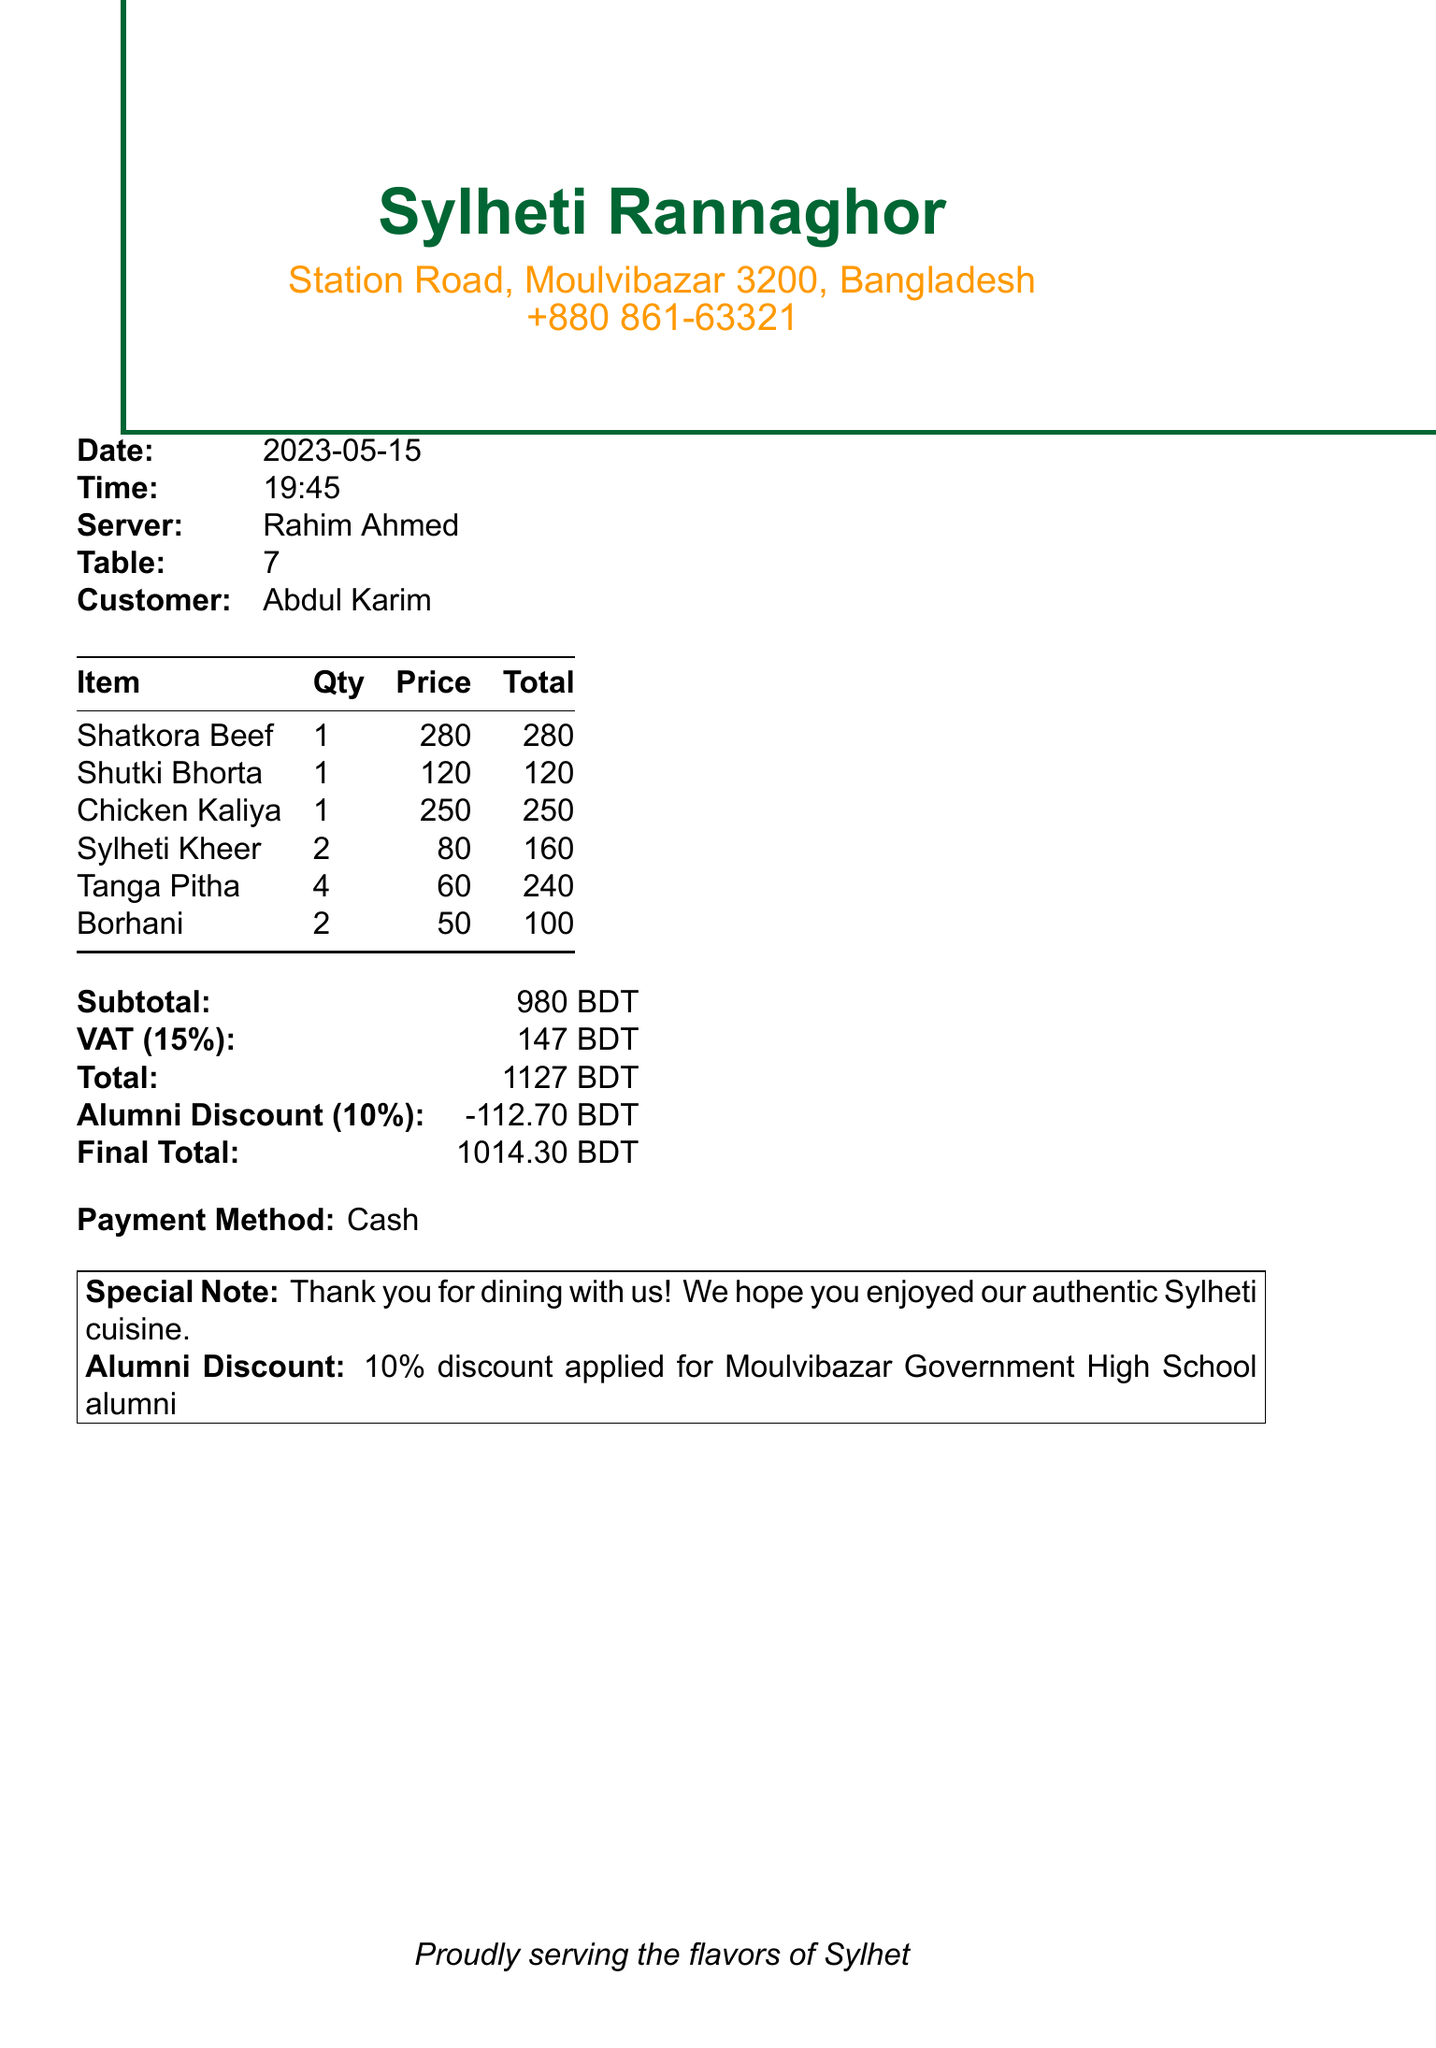What is the name of the restaurant? The name of the restaurant is located at the top of the document.
Answer: Sylheti Rannaghor What is the total amount before applying the alumni discount? The total amount before the discount is the sum of subtotal and VAT shown in the document.
Answer: 1127 BDT Who was the server? The server's name is listed near the date and time in the document.
Answer: Rahim Ahmed What is the quantity of Sylheti Kheer ordered? The quantity of Sylheti Kheer is specified in the items section of the receipt.
Answer: 2 What discount is applied for alumni? The discount applied for alumni is mentioned in the special note section.
Answer: 10% discount What is the final total after applying the discount? The final total reflects the total after the alumni discount is accounted for.
Answer: 1014.30 BDT What is the address of the restaurant? The restaurant's address is found near the name of the restaurant.
Answer: Station Road, Moulvibazar 3200, Bangladesh How many items were ordered in total? The total number of items is the sum of the quantities listed in the items section.
Answer: 10 What payment method was used? The payment method is noted in the payment method section of the document.
Answer: Cash 